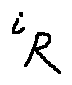<formula> <loc_0><loc_0><loc_500><loc_500>i _ { R }</formula> 